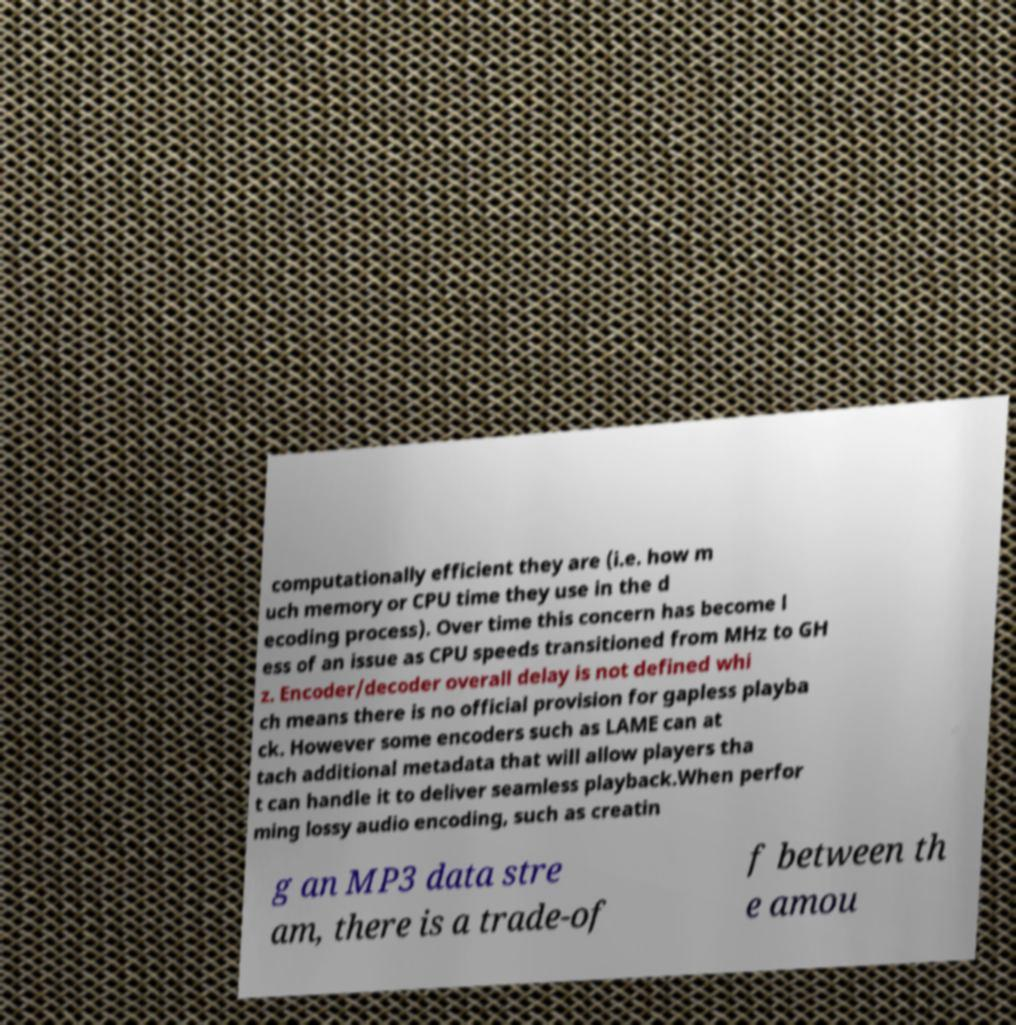What messages or text are displayed in this image? I need them in a readable, typed format. computationally efficient they are (i.e. how m uch memory or CPU time they use in the d ecoding process). Over time this concern has become l ess of an issue as CPU speeds transitioned from MHz to GH z. Encoder/decoder overall delay is not defined whi ch means there is no official provision for gapless playba ck. However some encoders such as LAME can at tach additional metadata that will allow players tha t can handle it to deliver seamless playback.When perfor ming lossy audio encoding, such as creatin g an MP3 data stre am, there is a trade-of f between th e amou 